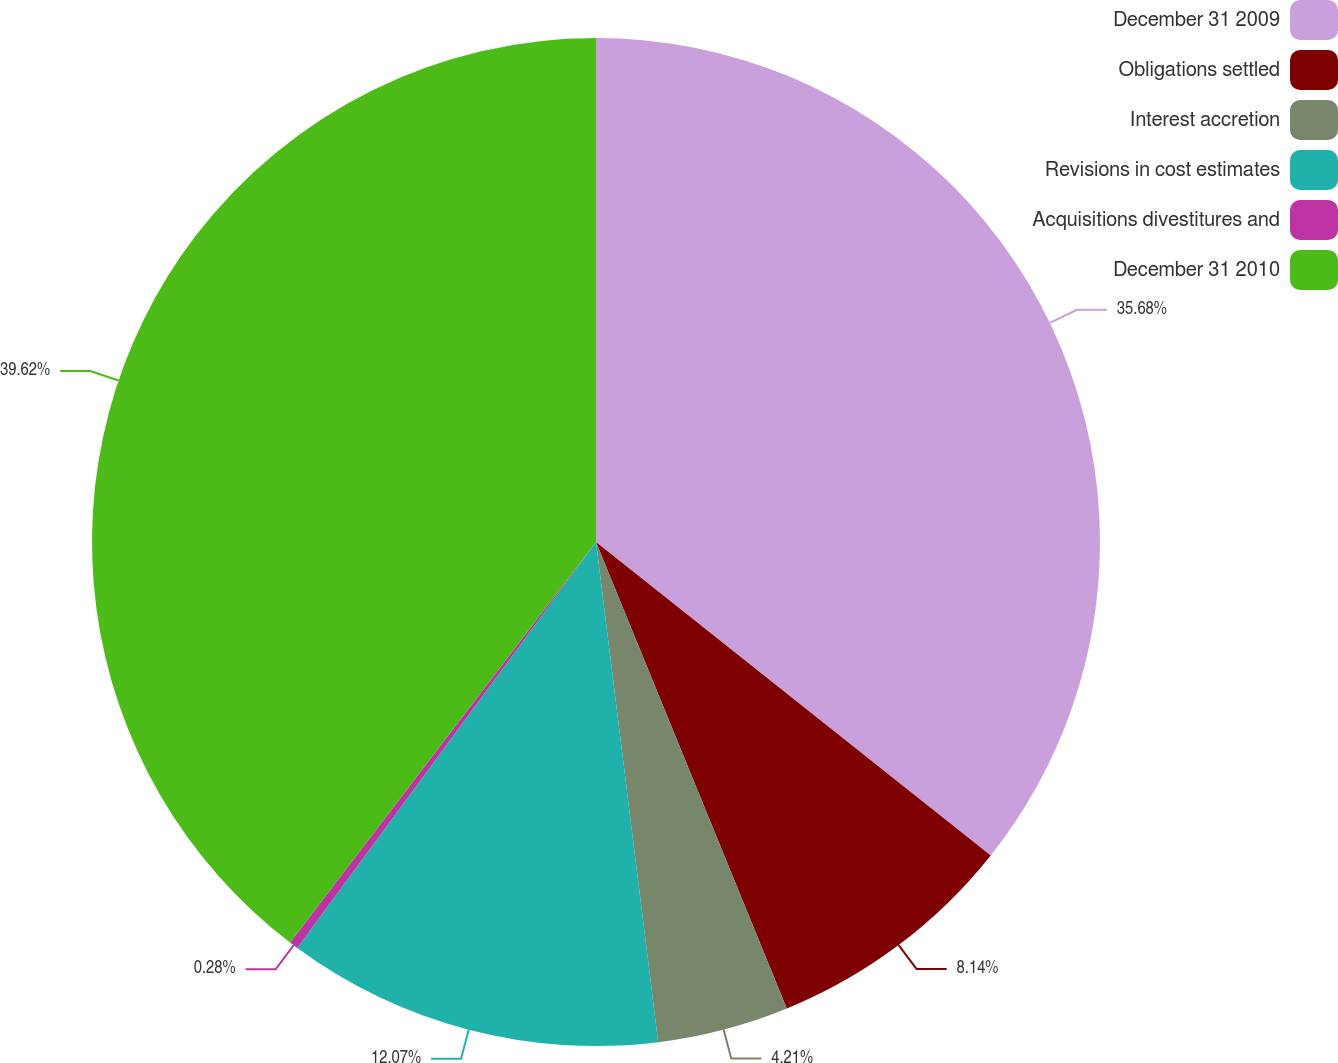Convert chart to OTSL. <chart><loc_0><loc_0><loc_500><loc_500><pie_chart><fcel>December 31 2009<fcel>Obligations settled<fcel>Interest accretion<fcel>Revisions in cost estimates<fcel>Acquisitions divestitures and<fcel>December 31 2010<nl><fcel>35.68%<fcel>8.14%<fcel>4.21%<fcel>12.07%<fcel>0.28%<fcel>39.62%<nl></chart> 